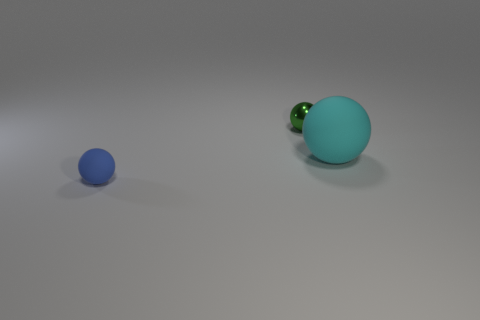What might be the size difference between these two balls? Based on the image, the turquoise ball is significantly larger than the blue ball, possibly around three to four times larger in diameter. 